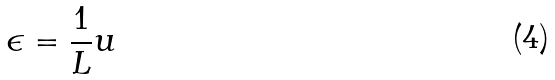Convert formula to latex. <formula><loc_0><loc_0><loc_500><loc_500>\epsilon = \frac { 1 } { L } u</formula> 